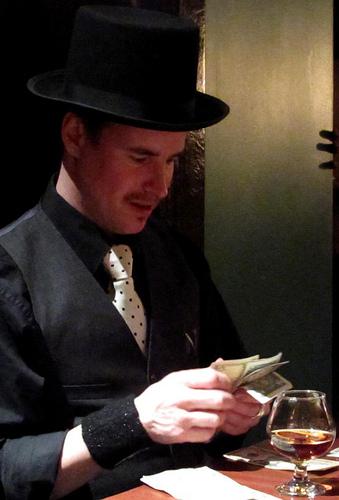Is the person wearing a ball cap?
Give a very brief answer. No. Is he drinking anything?
Give a very brief answer. Yes. What design is on his tie?
Concise answer only. Polka dots. Is that US currency that he is holding?
Write a very short answer. Yes. What type of drink does he have?
Keep it brief. Wine. 